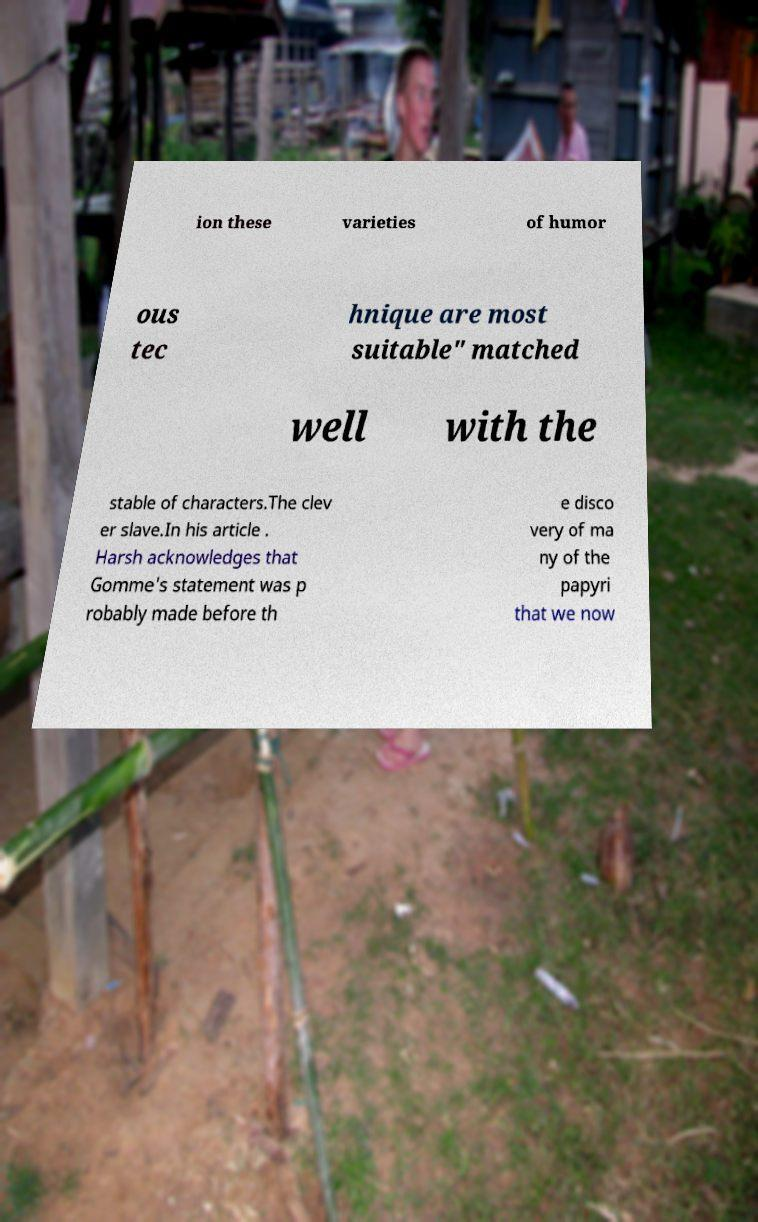There's text embedded in this image that I need extracted. Can you transcribe it verbatim? ion these varieties of humor ous tec hnique are most suitable" matched well with the stable of characters.The clev er slave.In his article . Harsh acknowledges that Gomme's statement was p robably made before th e disco very of ma ny of the papyri that we now 